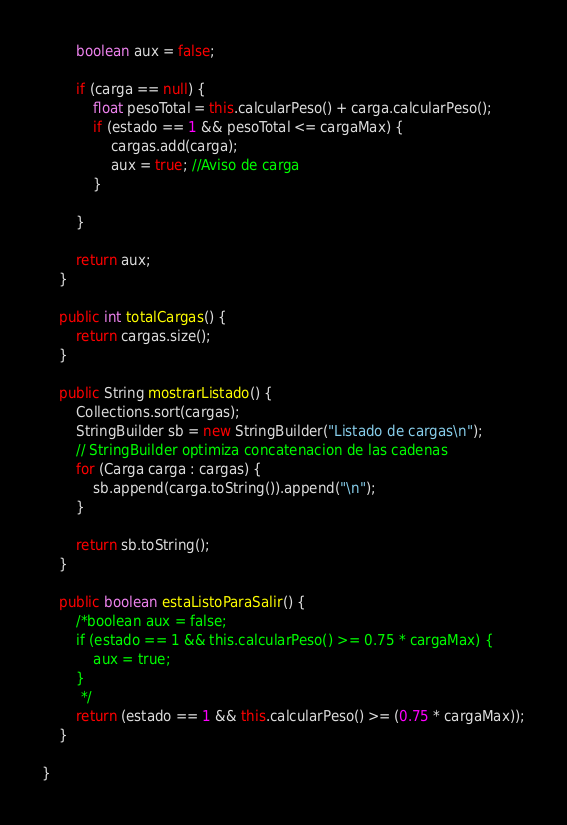Convert code to text. <code><loc_0><loc_0><loc_500><loc_500><_Java_>        boolean aux = false;

        if (carga == null) {
            float pesoTotal = this.calcularPeso() + carga.calcularPeso();
            if (estado == 1 && pesoTotal <= cargaMax) {
                cargas.add(carga);
                aux = true; //Aviso de carga
            }

        }

        return aux;
    }

    public int totalCargas() {
        return cargas.size();
    }

    public String mostrarListado() {
        Collections.sort(cargas);
        StringBuilder sb = new StringBuilder("Listado de cargas\n");
        // StringBuilder optimiza concatenacion de las cadenas
        for (Carga carga : cargas) {
            sb.append(carga.toString()).append("\n");
        }

        return sb.toString();
    }

    public boolean estaListoParaSalir() {
        /*boolean aux = false;
        if (estado == 1 && this.calcularPeso() >= 0.75 * cargaMax) {
            aux = true;
        }
         */
        return (estado == 1 && this.calcularPeso() >= (0.75 * cargaMax));
    }

}
</code> 